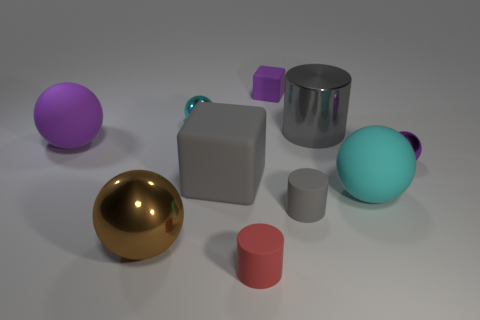Subtract 3 spheres. How many spheres are left? 2 Subtract all matte cylinders. How many cylinders are left? 1 Subtract all brown balls. How many balls are left? 4 Subtract all green spheres. Subtract all purple cylinders. How many spheres are left? 5 Subtract all cylinders. How many objects are left? 7 Add 6 big brown matte blocks. How many big brown matte blocks exist? 6 Subtract 0 purple cylinders. How many objects are left? 10 Subtract all large brown metallic balls. Subtract all big brown spheres. How many objects are left? 8 Add 1 big rubber objects. How many big rubber objects are left? 4 